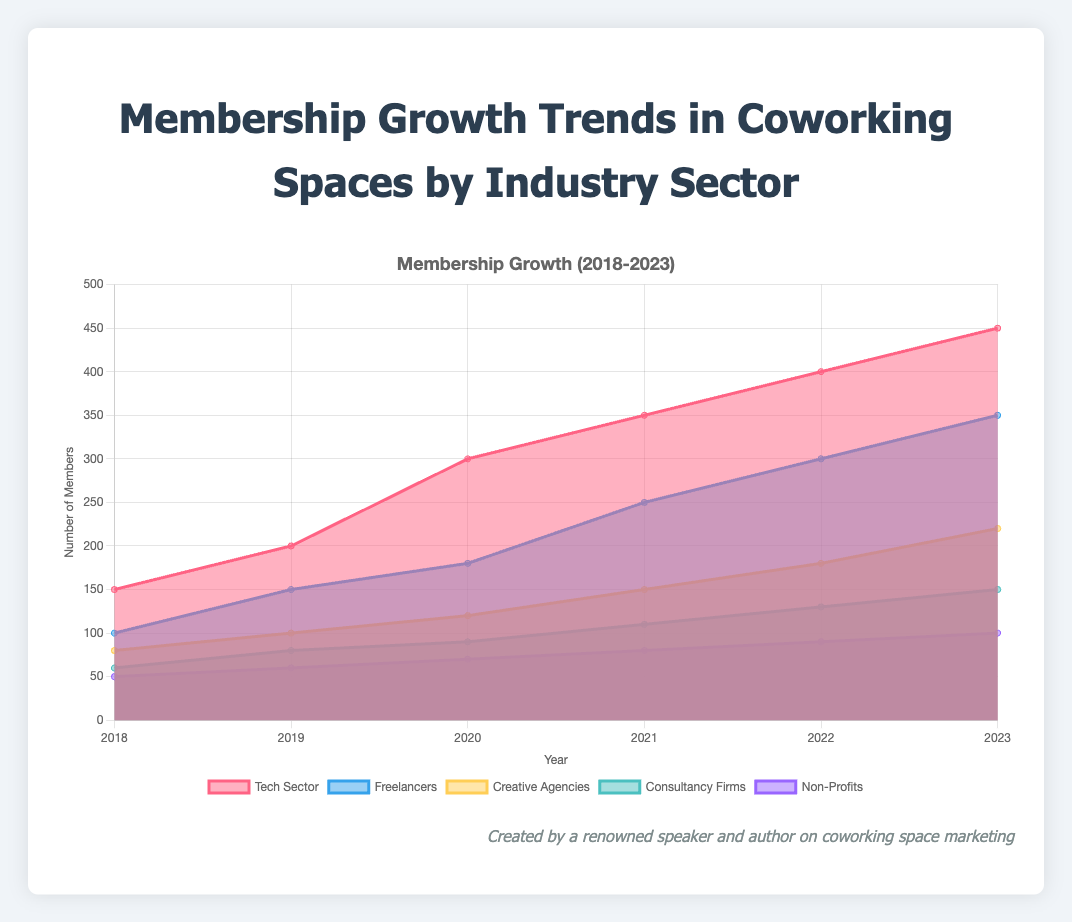Which industry sector had the highest membership growth in 2023? Look at the height of the colored areas for the year 2023 and identify which one is the highest. The Tech Sector has the tallest area in 2023.
Answer: Tech Sector What is the title of the chart? The title is located at the top of the chart and should provide a summary of what the chart represents.
Answer: Membership Growth Trends in Coworking Spaces by Industry Sector How many data points are represented for each industry sector? Count the number of marks or labeled data points on the x-axis for each sector. Since the x-axis spans from 2018 to 2023, there are 6 data points for each sector.
Answer: 6 data points Which two industry sectors had equal membership growth in 2019? Check the height of the areas for 2019 and see which sectors have the same level. Both Creative Agencies and Consultancy Firms have the same value of 100 members in 2019.
Answer: Creative Agencies and Consultancy Firms What is the total membership growth for Non-Profits from 2018 to 2023? Sum the values for each year: 50 (2018) + 60 (2019) + 70 (2020) + 80 (2021) + 90 (2022) + 100 (2023) = 450 members
Answer: 450 members What year did Freelancers see the highest annual growth compared to the previous year? Calculate the difference in membership growth for each adjacent year and find the maximum. Differences are: 50 (2018 to 2019), 30 (2019 to 2020), 70 (2020 to 2021), 50 (2021 to 2022), 50 (2022 to 2023). The highest growth was 70, from 2020 to 2021.
Answer: 2021 Which industry showed the least growth from 2018 to 2023? Compare the values for each sector in 2023 against the values in 2018 and check the smallest increase. Non-Profits increased from 50 to 100, which is the smallest jump of 50 members.
Answer: Non-Profits How did the membership trend for Creative Agencies change over the years? Observe the area representing Creative Agencies, starting at 80 in 2018 and gradually increasing each year until reaching 220 in 2023. The trend shows steady growth.
Answer: Steady growth Which sector showed constant growth without any decline between years? Look for a sector where the area always increases year-to-year without any dips. All sectors show growth with no decline between years.
Answer: All sectors What was the approximate difference in membership growth between Tech Sector and Non-Profits in 2022? Subtract the membership numbers for Non-Profits from the Tech Sector in 2022: 400 (Tech Sector) - 90 (Non-Profits) = 310
Answer: 310 members 